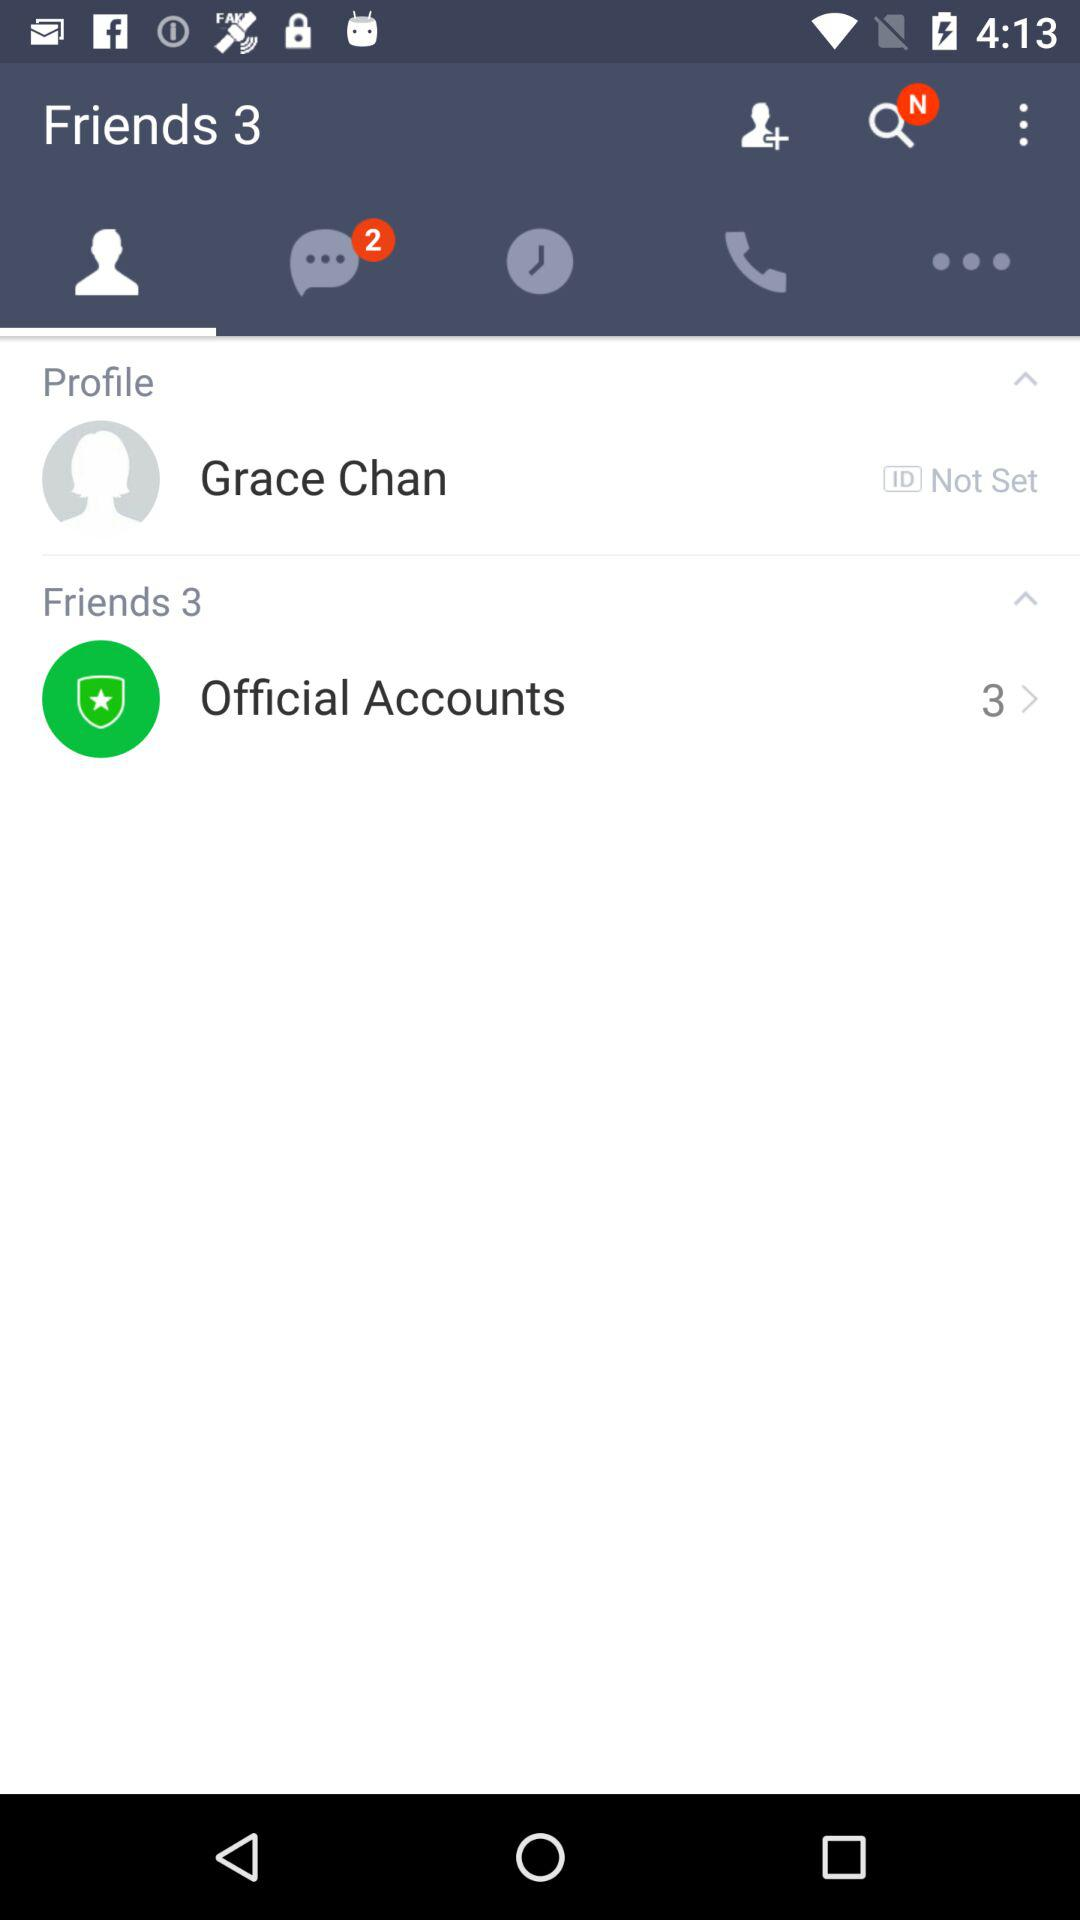How many unread messages are there? There are 2 unread messages. 